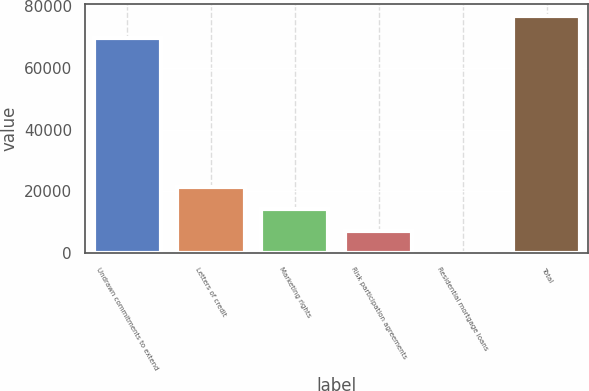<chart> <loc_0><loc_0><loc_500><loc_500><bar_chart><fcel>Undrawn commitments to extend<fcel>Letters of credit<fcel>Marketing rights<fcel>Risk participation agreements<fcel>Residential mortgage loans<fcel>Total<nl><fcel>69553<fcel>21525.2<fcel>14351.8<fcel>7178.4<fcel>5<fcel>76726.4<nl></chart> 